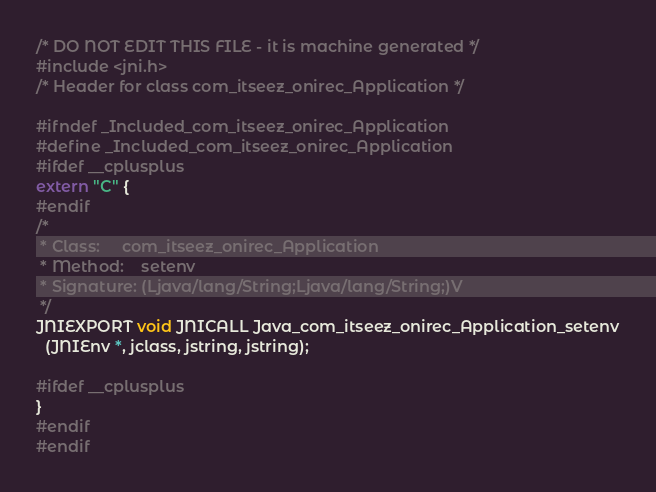Convert code to text. <code><loc_0><loc_0><loc_500><loc_500><_C_>/* DO NOT EDIT THIS FILE - it is machine generated */
#include <jni.h>
/* Header for class com_itseez_onirec_Application */

#ifndef _Included_com_itseez_onirec_Application
#define _Included_com_itseez_onirec_Application
#ifdef __cplusplus
extern "C" {
#endif
/*
 * Class:     com_itseez_onirec_Application
 * Method:    setenv
 * Signature: (Ljava/lang/String;Ljava/lang/String;)V
 */
JNIEXPORT void JNICALL Java_com_itseez_onirec_Application_setenv
  (JNIEnv *, jclass, jstring, jstring);

#ifdef __cplusplus
}
#endif
#endif
</code> 